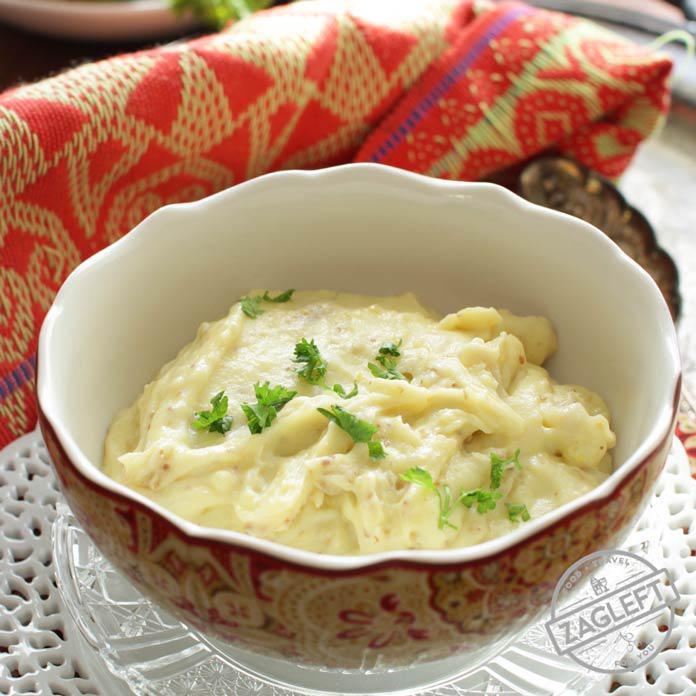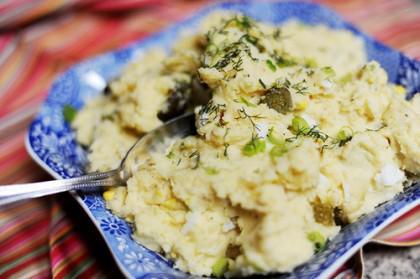The first image is the image on the left, the second image is the image on the right. Examine the images to the left and right. Is the description "There is a utensil sitting in the dish of food in the image on the right." accurate? Answer yes or no. Yes. The first image is the image on the left, the second image is the image on the right. Given the left and right images, does the statement "there is a serving spoon in the disg of potatoes" hold true? Answer yes or no. Yes. 